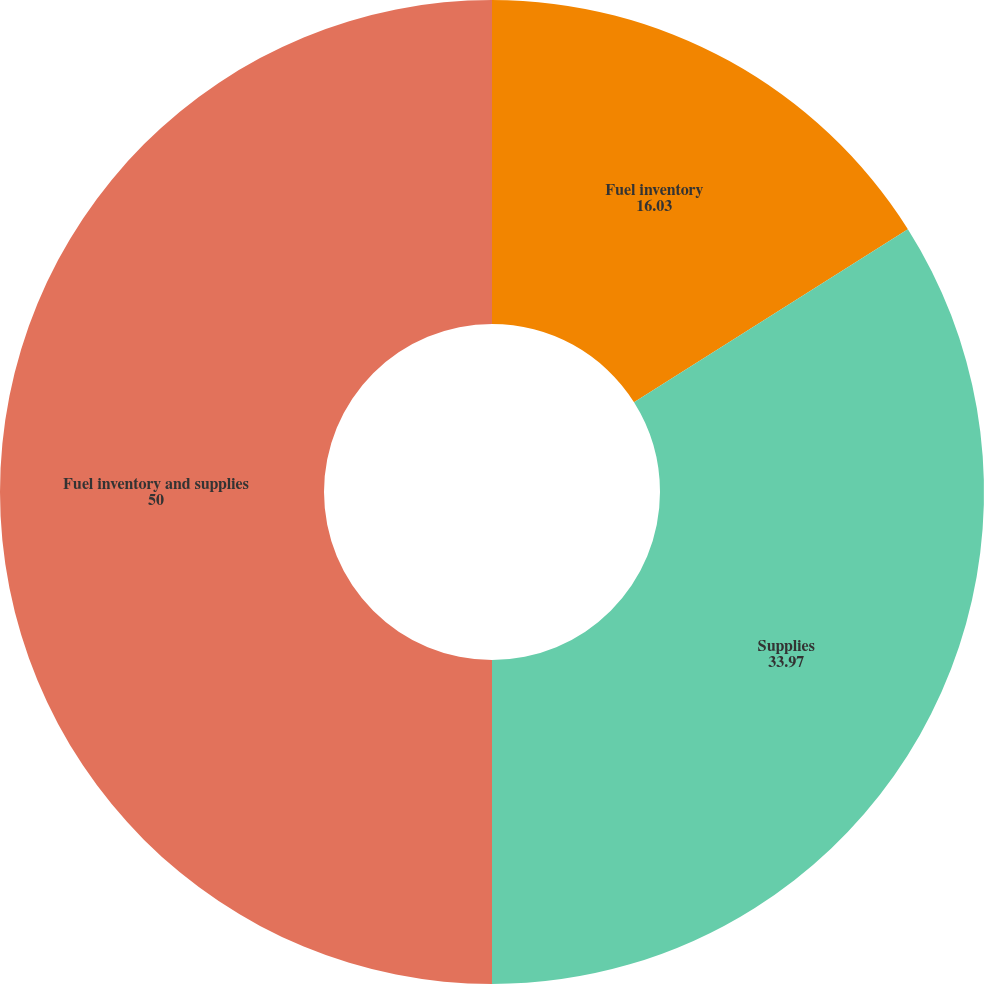<chart> <loc_0><loc_0><loc_500><loc_500><pie_chart><fcel>Fuel inventory<fcel>Supplies<fcel>Fuel inventory and supplies<nl><fcel>16.03%<fcel>33.97%<fcel>50.0%<nl></chart> 